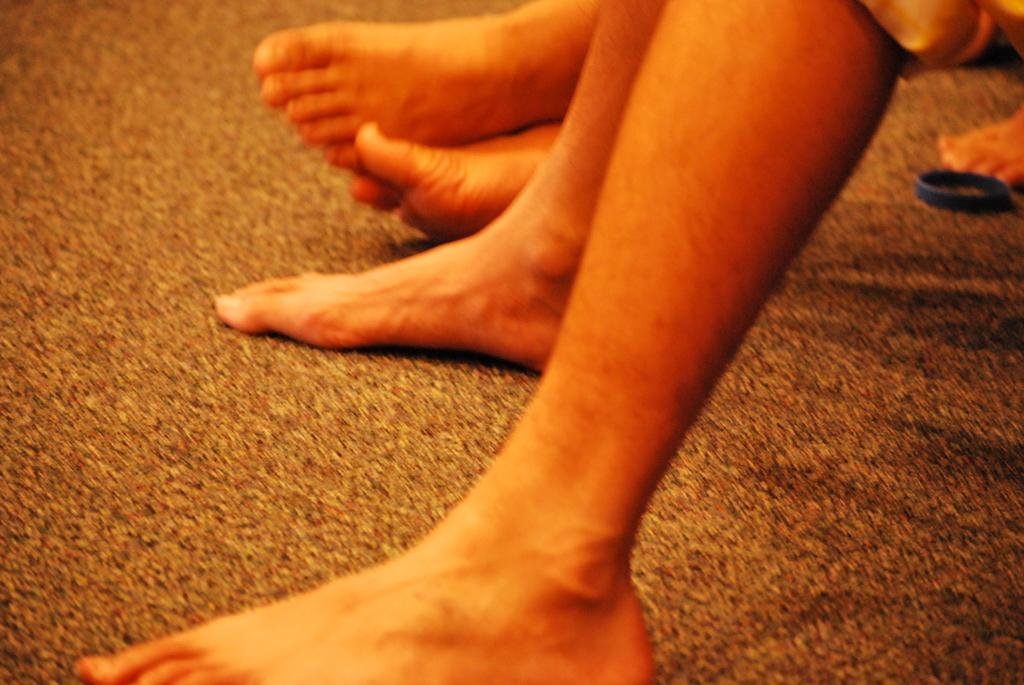How many people are represented by the legs in the image? There are legs of three persons in the image, suggesting that there are three people. What object can be seen on the right side of the image? There is a ring on the right side of the image. What role does the men's society play in the image? There is no mention of a men's society or any societal context in the image. 